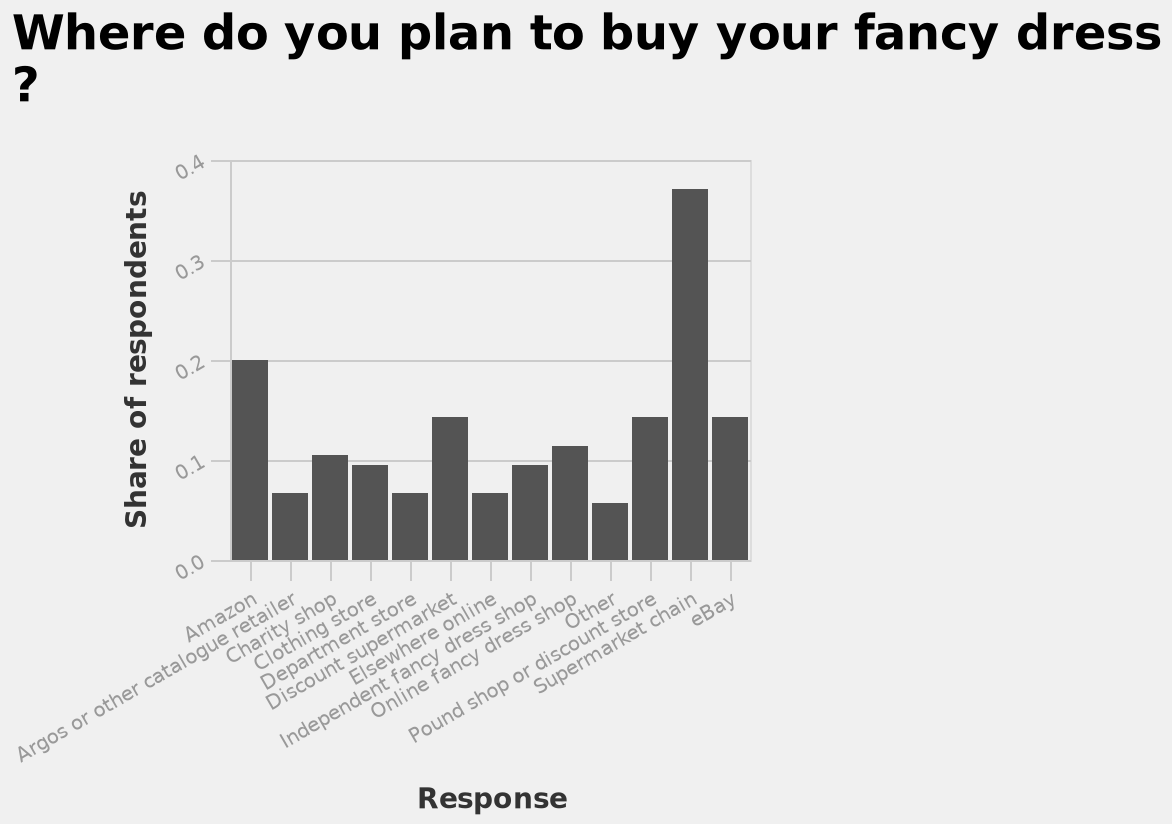<image>
Which end of the x-axis represents Amazon? Amazon is represented on one end of the x-axis in the bar diagram. Describe the following image in detail Where do you plan to buy your fancy dress ? is a bar diagram. The x-axis plots Response with categorical scale with Amazon on one end and eBay at the other while the y-axis measures Share of respondents using linear scale from 0.0 to 0.4. Is Apple represented on one end of the x-axis in the bar diagram? No.Amazon is represented on one end of the x-axis in the bar diagram. 